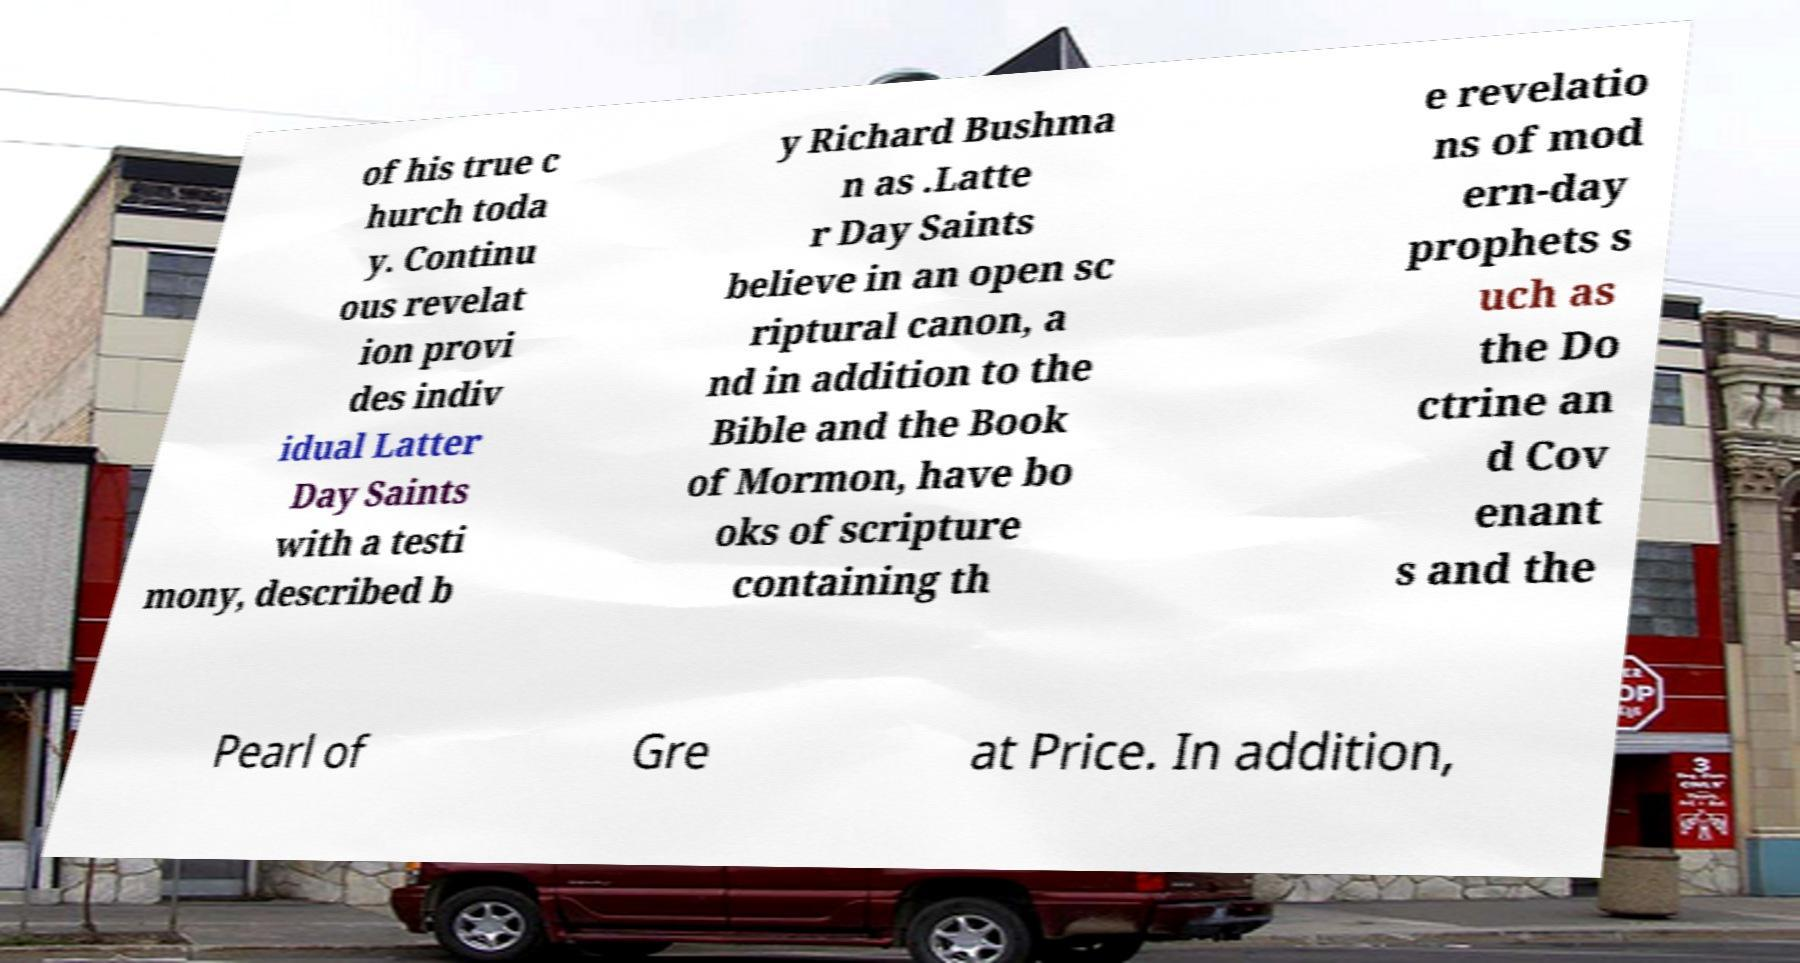Please identify and transcribe the text found in this image. of his true c hurch toda y. Continu ous revelat ion provi des indiv idual Latter Day Saints with a testi mony, described b y Richard Bushma n as .Latte r Day Saints believe in an open sc riptural canon, a nd in addition to the Bible and the Book of Mormon, have bo oks of scripture containing th e revelatio ns of mod ern-day prophets s uch as the Do ctrine an d Cov enant s and the Pearl of Gre at Price. In addition, 